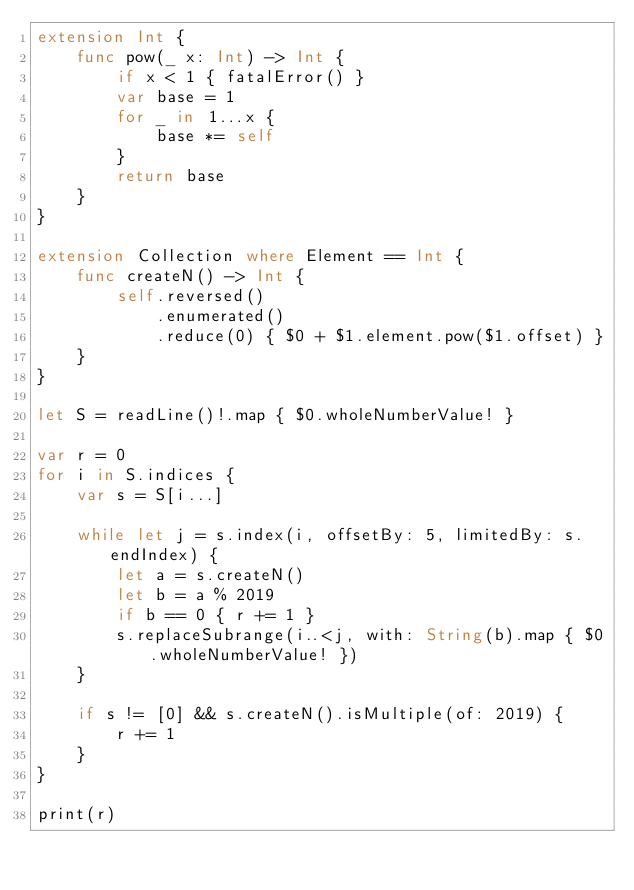Convert code to text. <code><loc_0><loc_0><loc_500><loc_500><_Swift_>extension Int {
    func pow(_ x: Int) -> Int {
        if x < 1 { fatalError() }
        var base = 1
        for _ in 1...x {
            base *= self
        }
        return base
    }
}

extension Collection where Element == Int {
    func createN() -> Int {
        self.reversed()
            .enumerated()
            .reduce(0) { $0 + $1.element.pow($1.offset) }
    }
}

let S = readLine()!.map { $0.wholeNumberValue! }

var r = 0
for i in S.indices {
    var s = S[i...]
    
    while let j = s.index(i, offsetBy: 5, limitedBy: s.endIndex) {
        let a = s.createN()
        let b = a % 2019
        if b == 0 { r += 1 }
        s.replaceSubrange(i..<j, with: String(b).map { $0.wholeNumberValue! })
    }
    
    if s != [0] && s.createN().isMultiple(of: 2019) {
        r += 1
    }
}

print(r)
</code> 